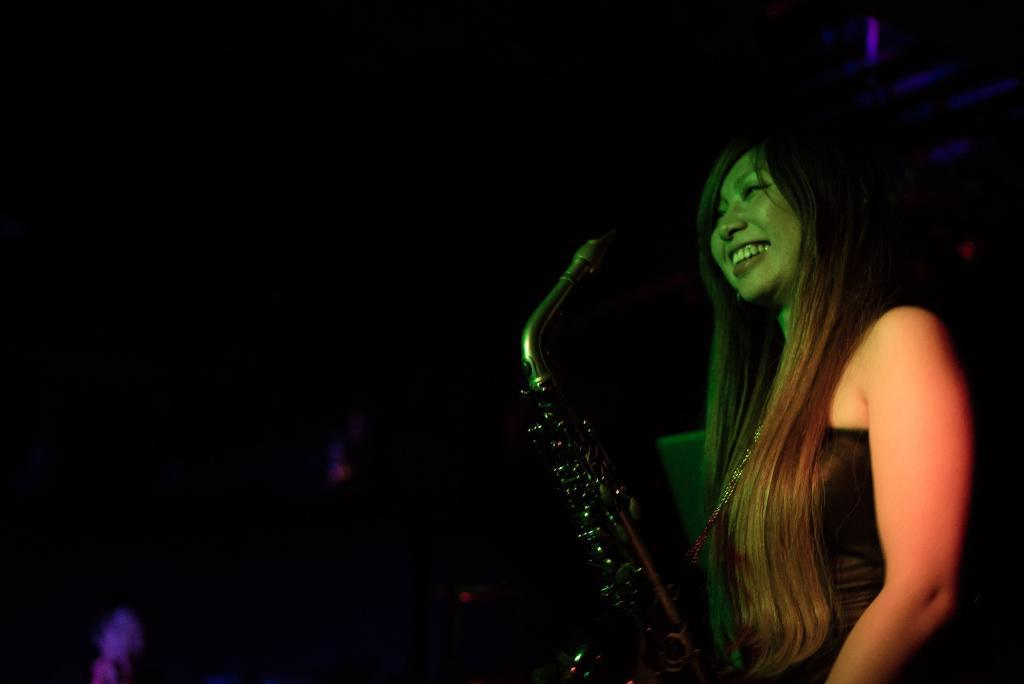Who is the main subject in the image? There is a woman in the image. What is the woman wearing? The woman is wearing a black dress. What is the woman holding in the image? The woman is holding a trombone. What can be observed about the background of the image? The background of the image is dark. What type of jeans is the woman wearing in the image? The woman is not wearing jeans in the image; she is wearing a black dress. What type of art can be seen hanging on the wall in the image? There is no art or wall visible in the image; it only features the woman holding a trombone against a dark background. 